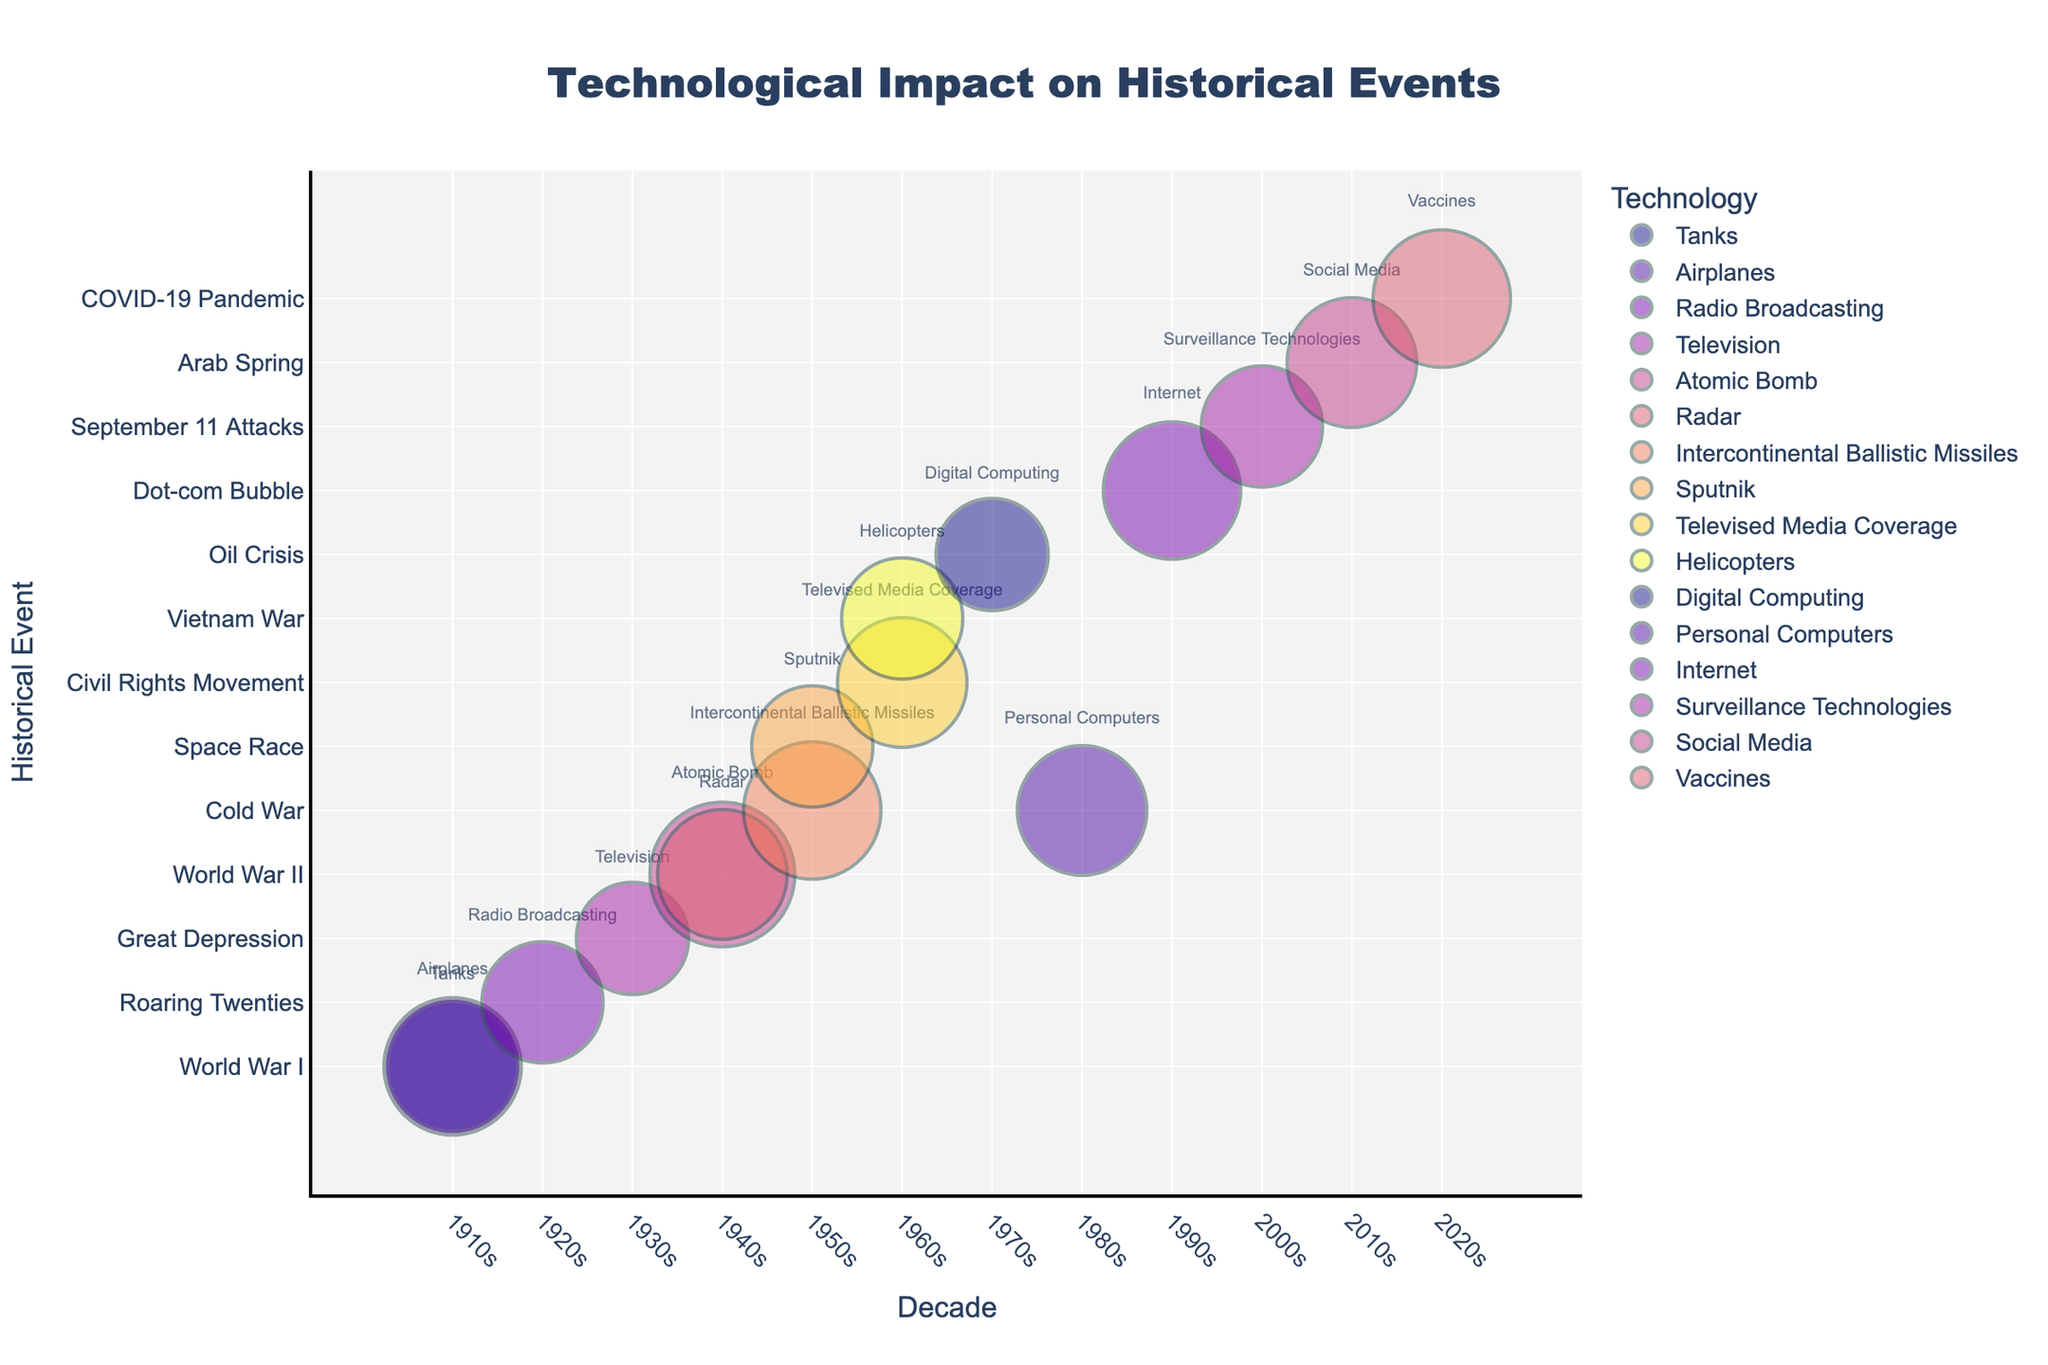How is the significance of technologies impacting events in the 1940s depicted in the chart? The chart shows two key technological impacts in the 1940s: the Atomic Bomb and Radar, with the sizes of the bubbles indicating their significance. The Atomic Bomb has a higher significance at 10, while Radar is slightly less at 8.
Answer: The Atomic Bomb has a significance of 10, and Radar has a significance of 8 What is the most significant technological impact recorded on this chart? The bubble representing the Atomic Bomb during World War II in the 1940s is the largest, signifying the highest impact with a significance of 10.
Answer: The Atomic Bomb during World War II How do the technological impacts of World War I compare with those of World War II? By examining the sizes of the bubbles for World War I and World War II, we see that World War II’s Atomic Bomb (significance 10) and Radar (significance 8) are both larger than World War I’s Tanks (significance 8) and Airplanes (significance 9).
Answer: World War II impacts are generally more significant Which decade has the most diverse types of technological impacts? Analyzing the number of different technologies per decade, the 1940s and the 1950s both feature two distinct technologies: World War II with Atomic Bomb and Radar in the 1940s, and Cold War with ICBMs and Space Race with Sputnik in the 1950s.
Answer: 1940s and 1950s Which technological event in the 1990s had the most significant impact? The 1990s show a single technological event: the Dot-com Bubble with the Internet, represented by a large bubble, indicating a high significance of 9.
Answer: The Dot-com Bubble with the Internet Between the Civil Rights Movement and the Vietnam War, which one was more significantly impacted by technology? The chart shows the Civil Rights Movement with Televised Media Coverage (significance 8) and the Vietnam War with Helicopters (significance 7). Therefore, the Civil Rights Movement had a more significant impact.
Answer: Civil Rights Movement with Televised Media Coverage What is the average significance of technological impacts in the 1960s? The 1960s show two impacts: Televised Media Coverage (8) and Helicopters (7). Their average significance is calculated as (8 + 7) / 2 = 7.5.
Answer: 7.5 Which event had the highest similarity in significance to the Roaring Twenties' Radio Broadcasting? The chart shows the Roaring Twenties' Radio Broadcasting with a significance of 7. Comparing all other bubble sizes, both the Great Depression with Television and the Space Race with Sputnik also have a significance of 7, indicating similar impacts.
Answer: Great Depression with Television and Space Race with Sputnik What technological event in the 2010s had an impact of significance 8? The chart indicates that Social Media during the Arab Spring in the 2010s had a significance of 8, represented by a correspondingly sized bubble.
Answer: Arab Spring with Social Media 